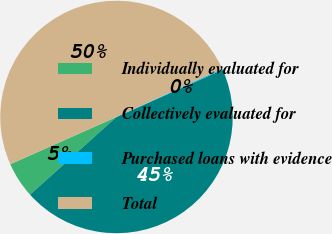Convert chart. <chart><loc_0><loc_0><loc_500><loc_500><pie_chart><fcel>Individually evaluated for<fcel>Collectively evaluated for<fcel>Purchased loans with evidence<fcel>Total<nl><fcel>4.99%<fcel>45.01%<fcel>0.16%<fcel>49.84%<nl></chart> 